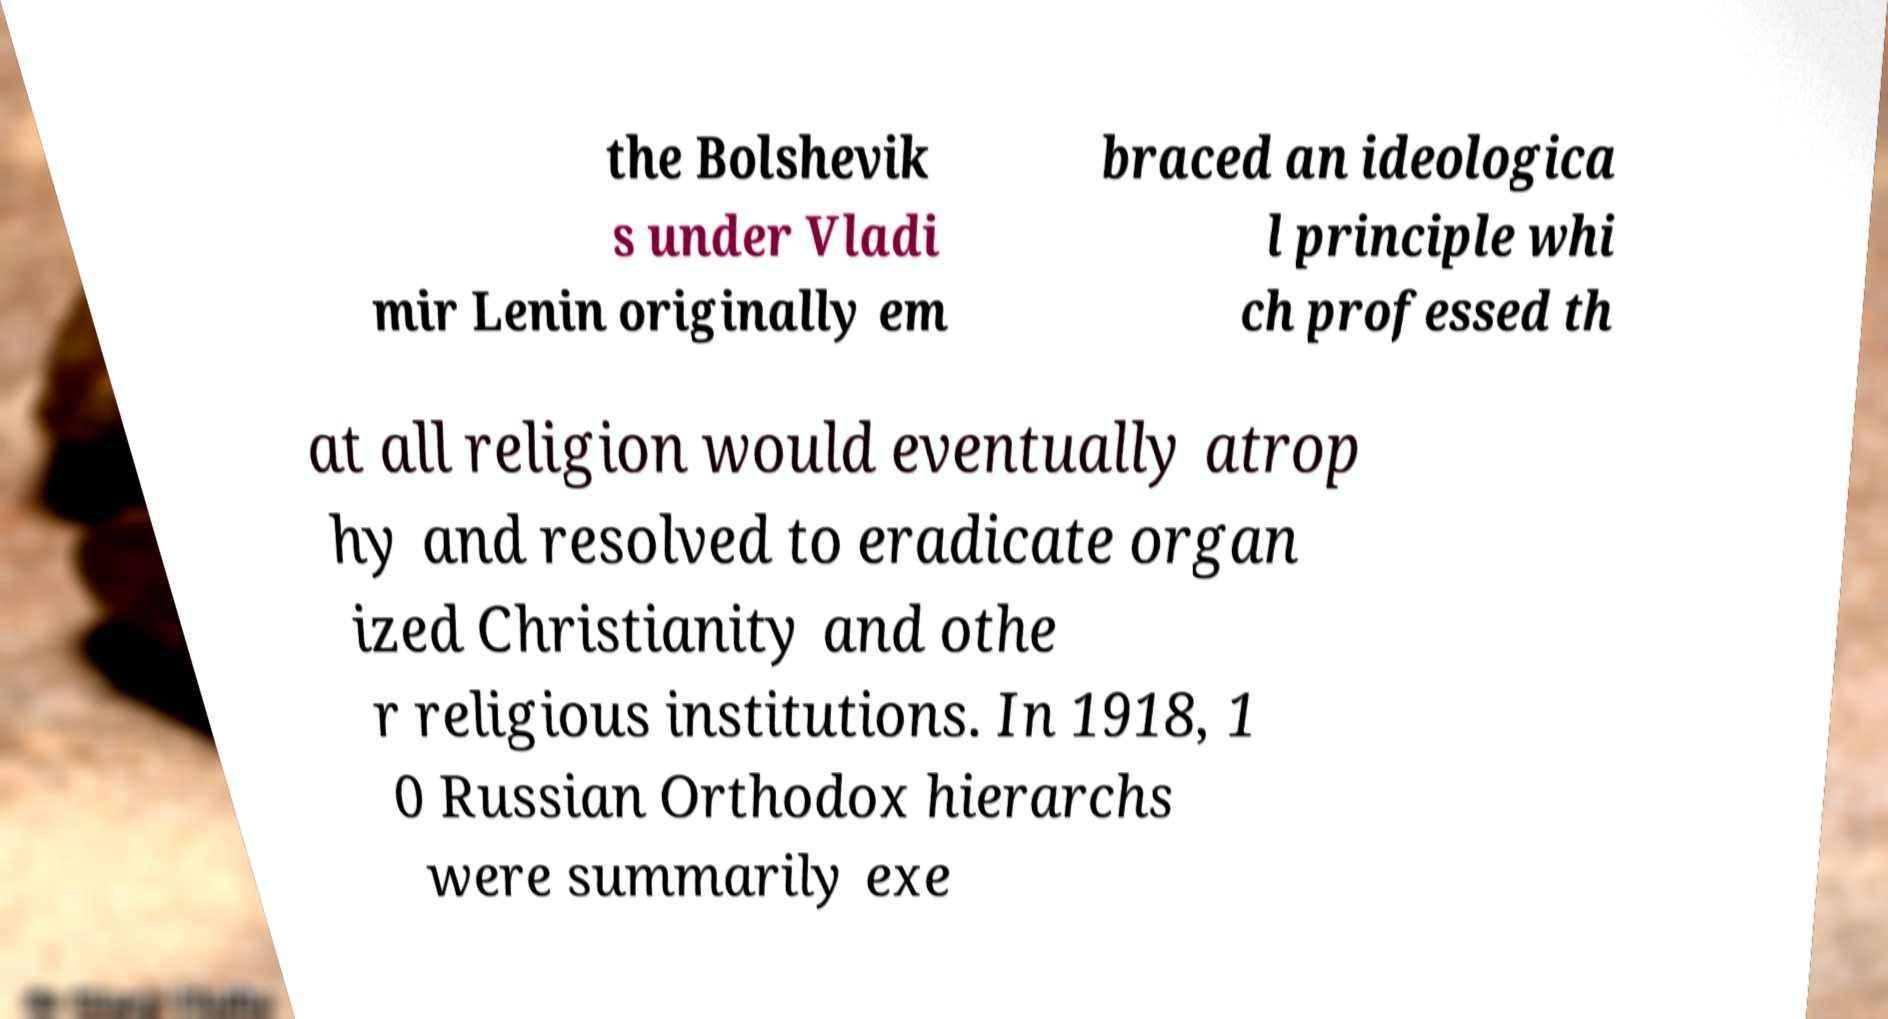I need the written content from this picture converted into text. Can you do that? the Bolshevik s under Vladi mir Lenin originally em braced an ideologica l principle whi ch professed th at all religion would eventually atrop hy and resolved to eradicate organ ized Christianity and othe r religious institutions. In 1918, 1 0 Russian Orthodox hierarchs were summarily exe 